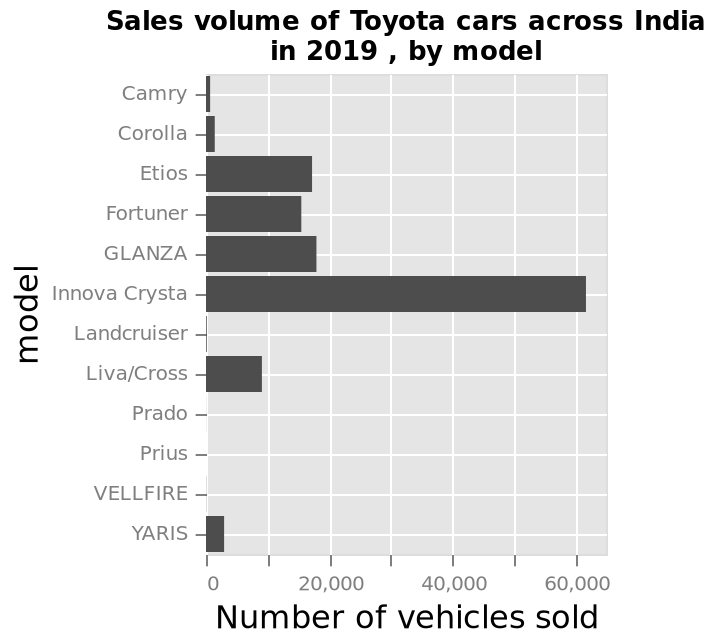<image>
What is the main focus of the chart? The chart focuses on showcasing the sales volume of different Toyota car models in India during the year 2019. How many models have not sold any units? Four models have not sold any units. Describe the following image in detail Sales volume of Toyota cars across India in 2019 , by model is a bar chart. The y-axis measures model while the x-axis shows Number of vehicles sold. 